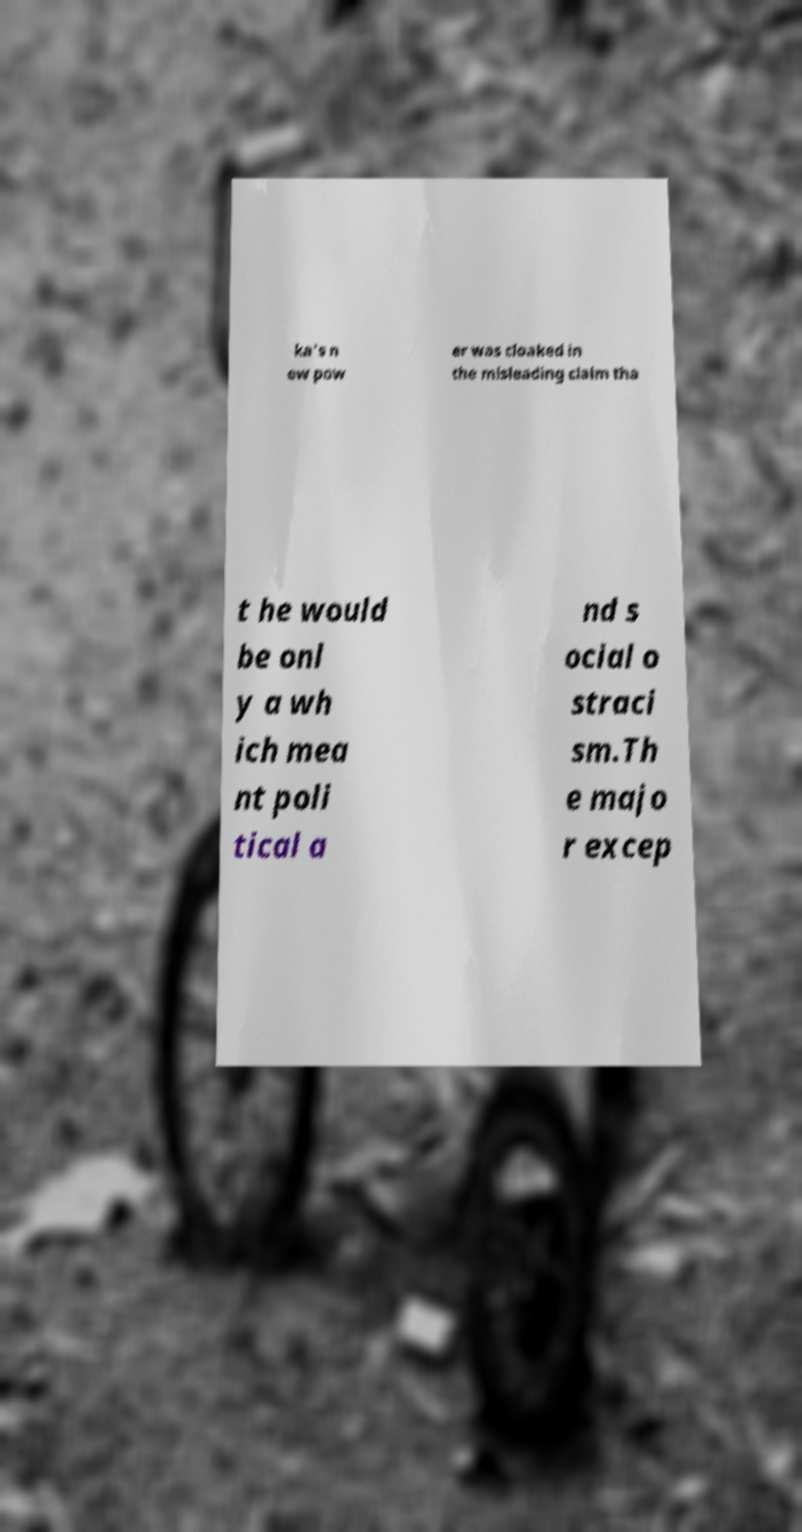Can you accurately transcribe the text from the provided image for me? ka's n ew pow er was cloaked in the misleading claim tha t he would be onl y a wh ich mea nt poli tical a nd s ocial o straci sm.Th e majo r excep 